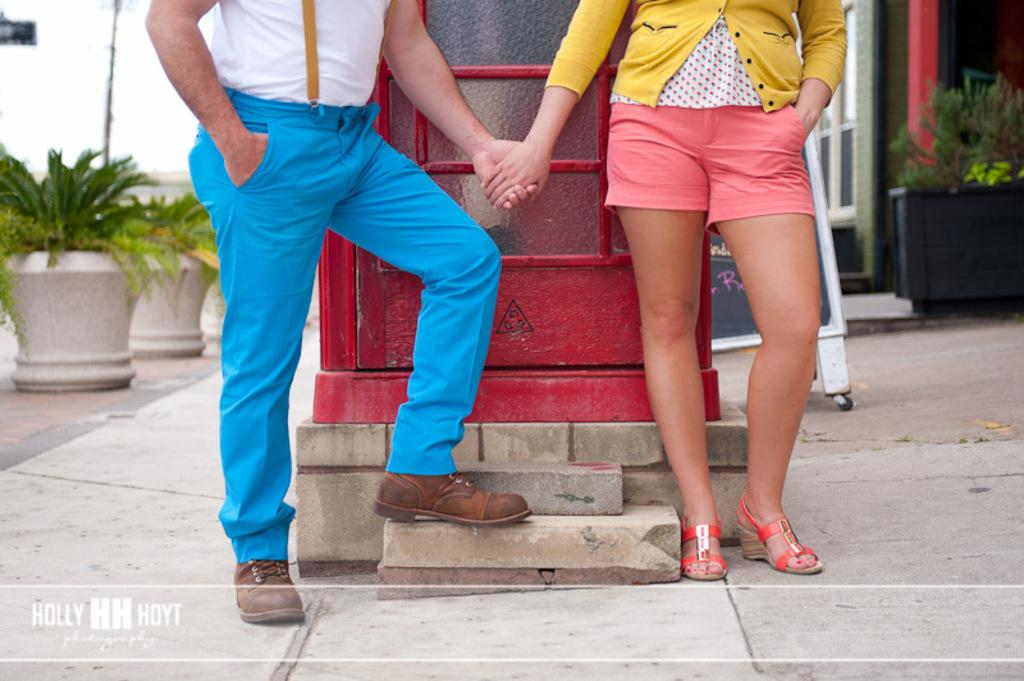Who is present in the image? There is a couple in the image. What are the couple doing in the image? The couple is standing in the front and holding their hands. What can be seen in the background of the image? There is a red phone booth in the background. What type of objects are present near the couple? There are white plant pots in the image. How many jellyfish are swimming in the image? There are no jellyfish present in the image. What appliance is the couple using to communicate in the image? There is no appliance visible in the image, and the couple is not communicating with each other through any device. 